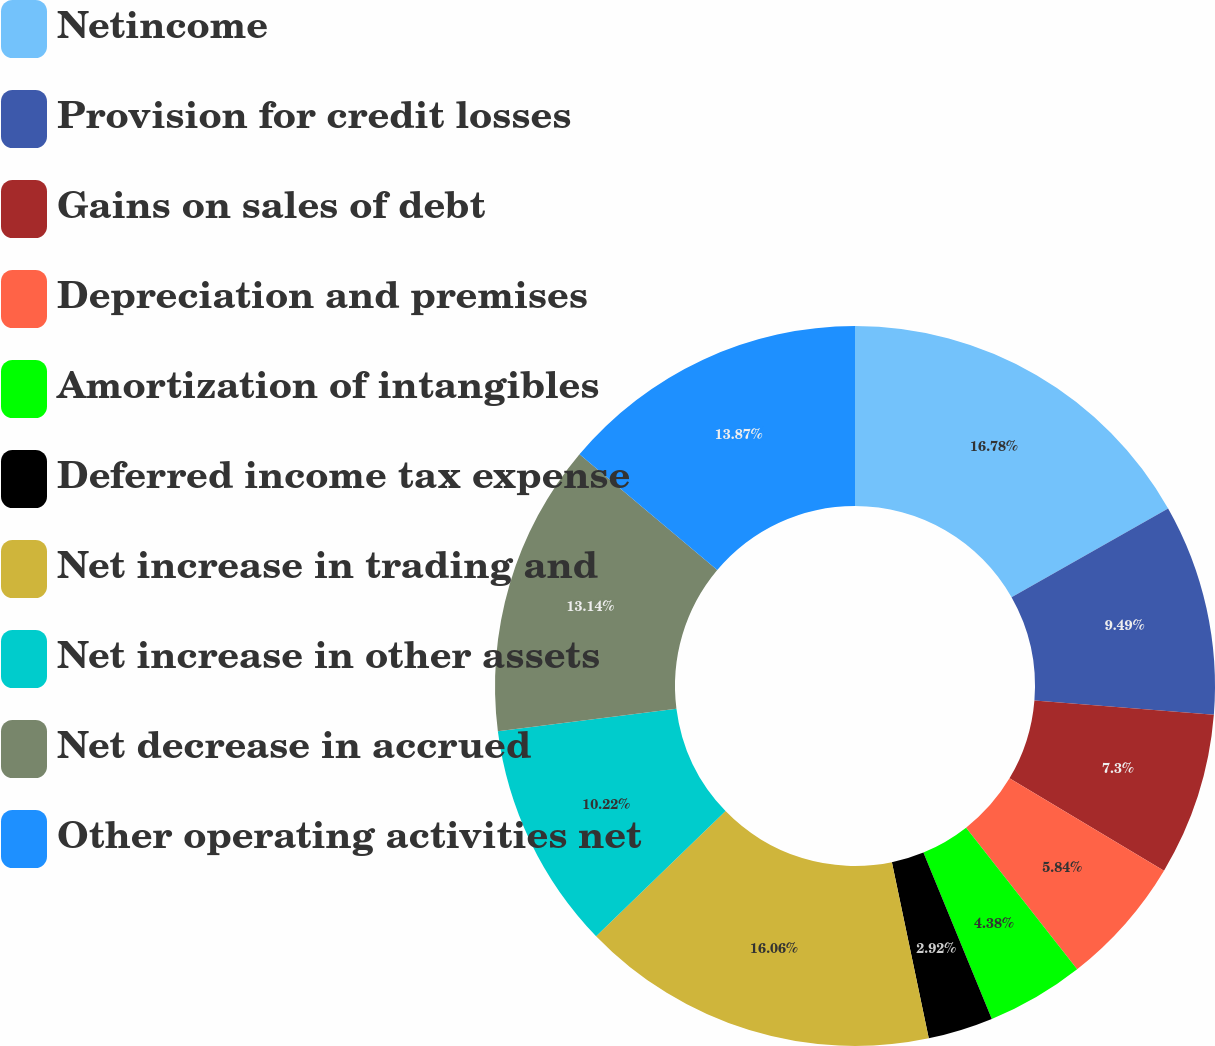Convert chart. <chart><loc_0><loc_0><loc_500><loc_500><pie_chart><fcel>Netincome<fcel>Provision for credit losses<fcel>Gains on sales of debt<fcel>Depreciation and premises<fcel>Amortization of intangibles<fcel>Deferred income tax expense<fcel>Net increase in trading and<fcel>Net increase in other assets<fcel>Net decrease in accrued<fcel>Other operating activities net<nl><fcel>16.79%<fcel>9.49%<fcel>7.3%<fcel>5.84%<fcel>4.38%<fcel>2.92%<fcel>16.06%<fcel>10.22%<fcel>13.14%<fcel>13.87%<nl></chart> 